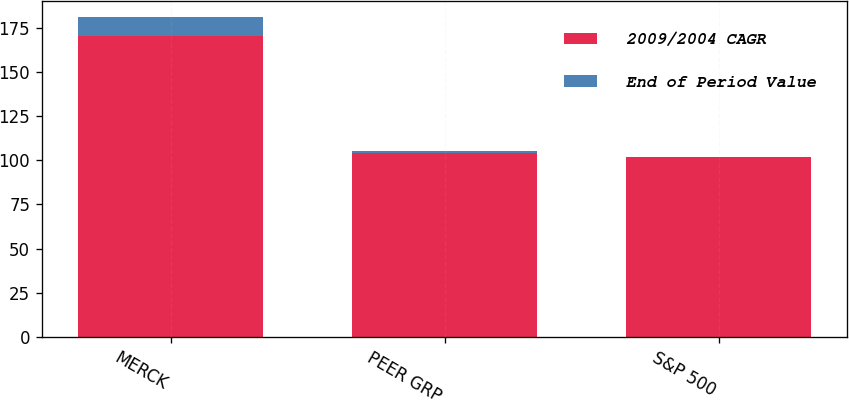Convert chart to OTSL. <chart><loc_0><loc_0><loc_500><loc_500><stacked_bar_chart><ecel><fcel>MERCK<fcel>PEER GRP<fcel>S&P 500<nl><fcel>2009/2004 CAGR<fcel>170<fcel>104<fcel>102<nl><fcel>End of Period Value<fcel>11<fcel>1<fcel>0<nl></chart> 